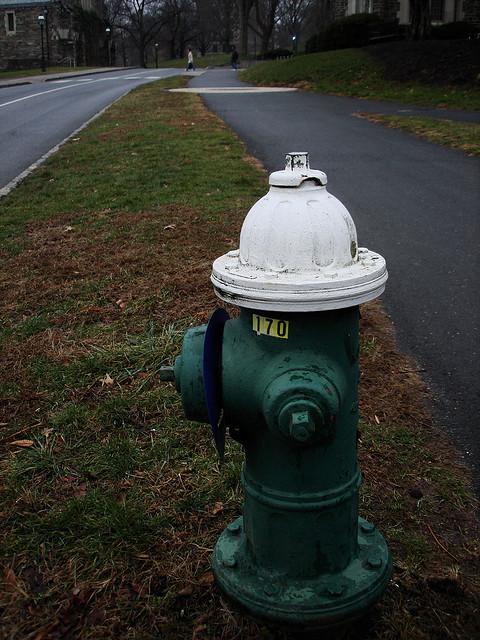How many chains are on the fire hydrant?
Answer briefly. 0. Is the paint on the hydrant fresh?
Short answer required. No. Does the sidewalk have a crack in it?
Give a very brief answer. No. What color is this fire hydrant?
Give a very brief answer. Green. What color is the hydrant?
Short answer required. Green. Does the fire hydrant work?
Write a very short answer. Yes. Is this a residential or commercial zone?
Write a very short answer. Residential. Does this look like the typical fire hydrants you have in your neighborhood?
Quick response, please. No. Is the grass tall?
Give a very brief answer. No. What color is this item usually?
Keep it brief. Red. What color is the part?
Keep it brief. Green. What is behind the fire hydrant?
Concise answer only. Grass. Is this fire hydrant on a sidewalk?
Concise answer only. No. What is this used for?
Short answer required. Putting out fires. Is this clean?
Quick response, please. Yes. What color is the fire hydrant bottom?
Concise answer only. Green. 